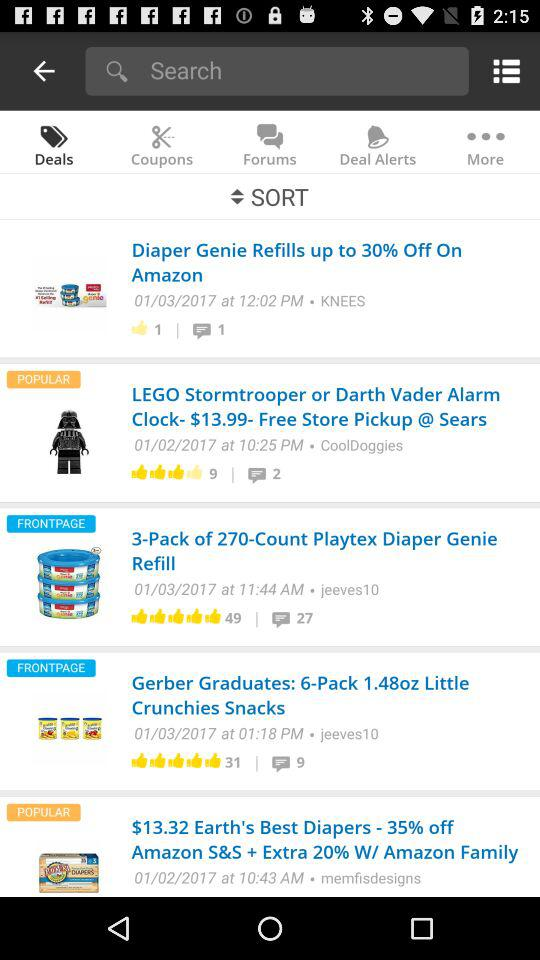How many likes on Diaper Genie Refills? There is 1 like. 